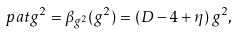<formula> <loc_0><loc_0><loc_500><loc_500>\ p a t g ^ { 2 } = \beta _ { g ^ { 2 } } ( g ^ { 2 } ) = ( D - 4 + \eta ) \, g ^ { 2 } ,</formula> 